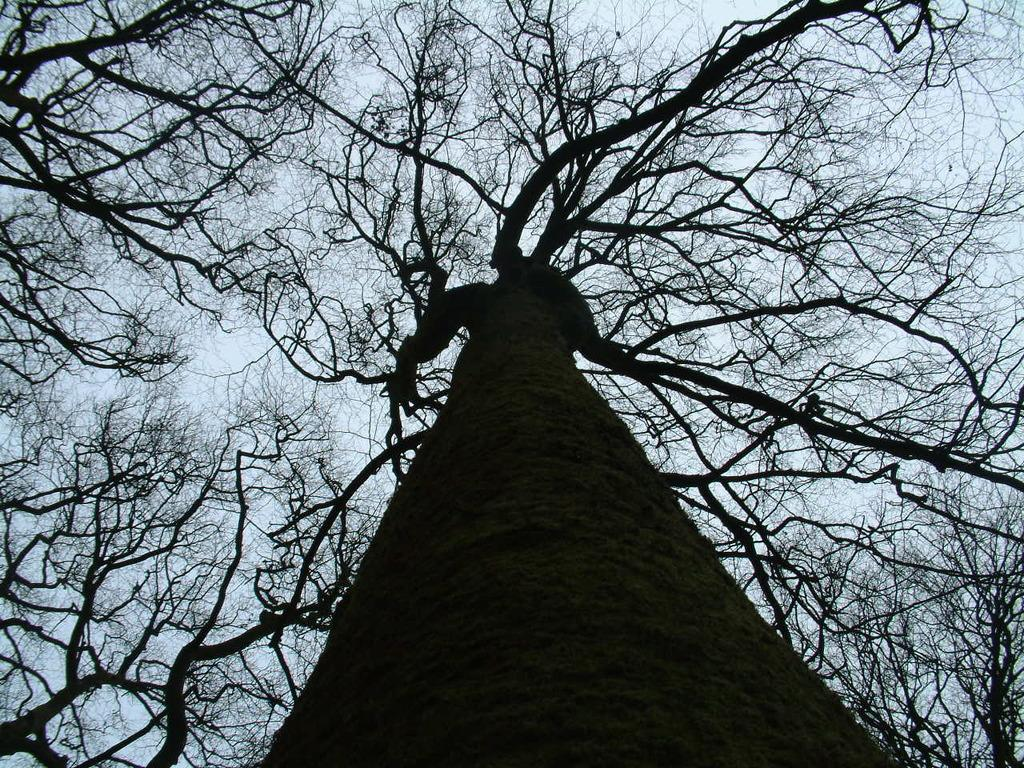What type of vegetation can be seen in the image? There are trees in the image. What is the condition of the sky in the image? The sky is cloudy in the image. Can you see any waves in the image? There are no waves present in the image, as it features trees and a cloudy sky. What type of treatment is being administered to the trees in the image? There is no treatment being administered to the trees in the image; they are simply standing in the landscape. 